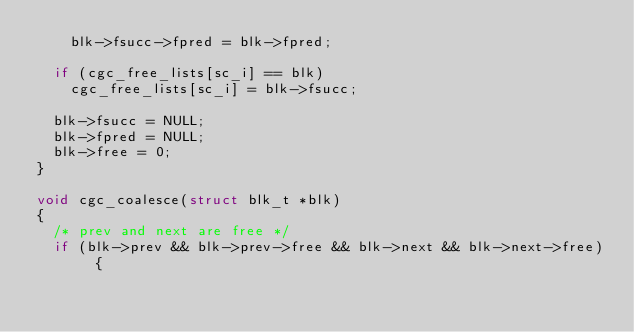Convert code to text. <code><loc_0><loc_0><loc_500><loc_500><_C_>    blk->fsucc->fpred = blk->fpred;

  if (cgc_free_lists[sc_i] == blk)
    cgc_free_lists[sc_i] = blk->fsucc;

  blk->fsucc = NULL;
  blk->fpred = NULL;
  blk->free = 0;
}

void cgc_coalesce(struct blk_t *blk)
{
  /* prev and next are free */
  if (blk->prev && blk->prev->free && blk->next && blk->next->free) {</code> 